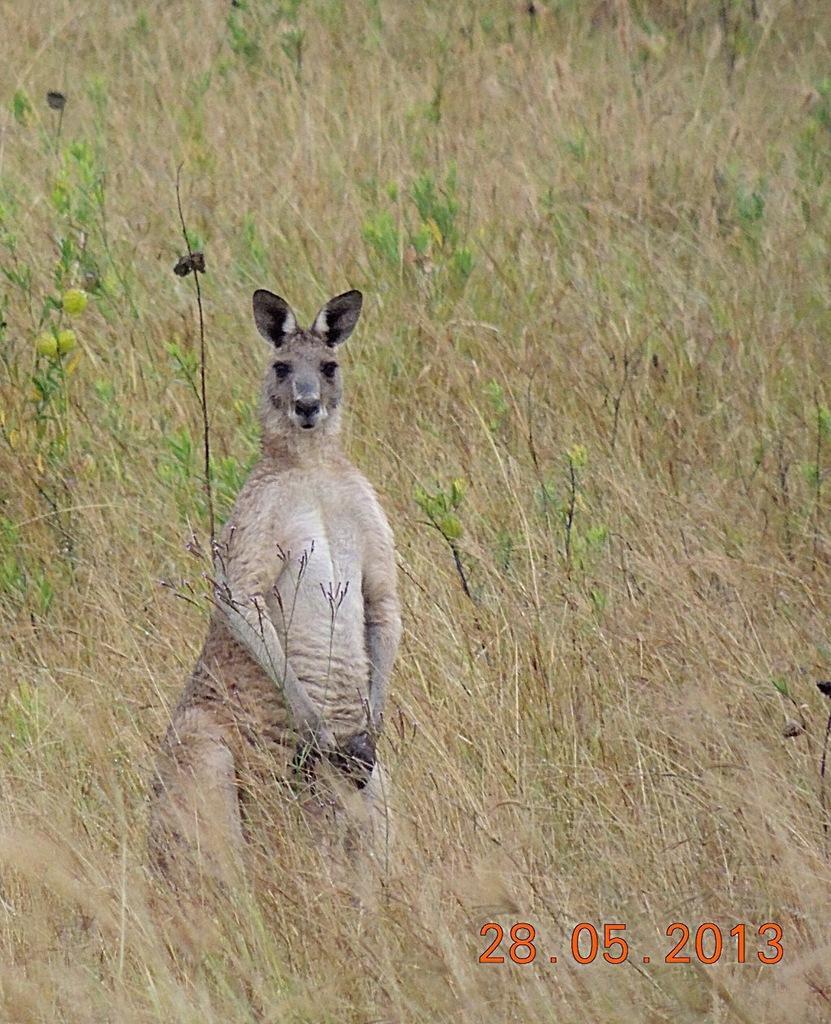Please provide a concise description of this image. We can see the kangaroo on the grass on the ground. In the background there are plants and grass on the ground. On the right side at the bottom corner we can see the date on the image. 